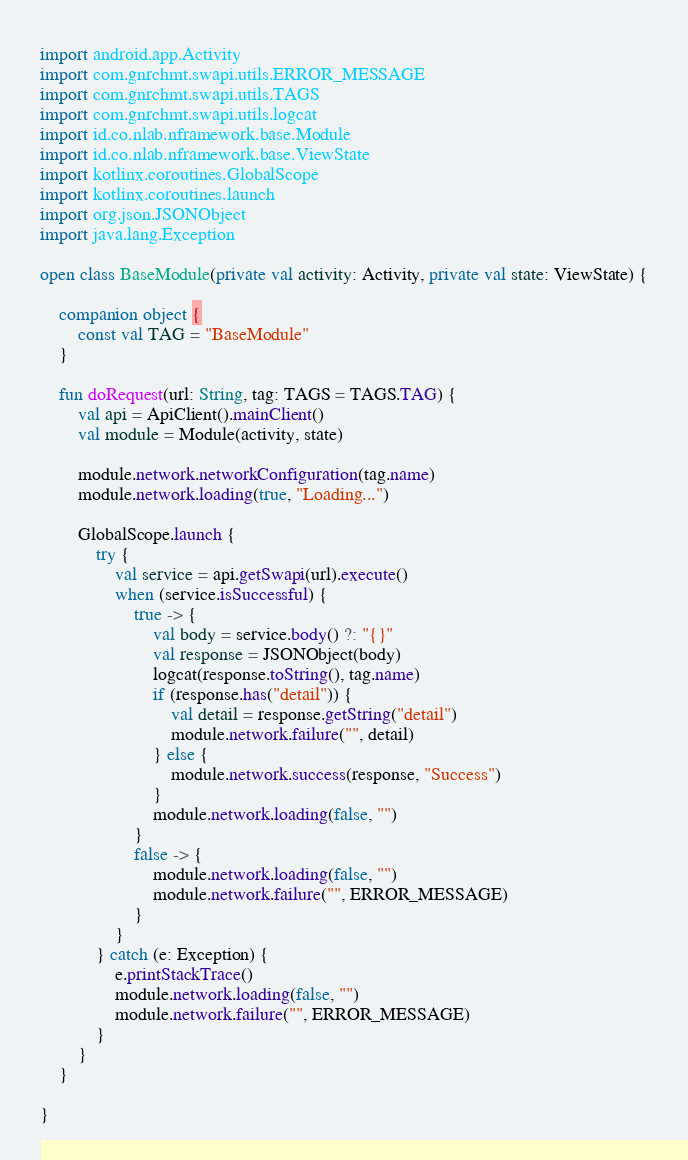Convert code to text. <code><loc_0><loc_0><loc_500><loc_500><_Kotlin_>
import android.app.Activity
import com.gnrchmt.swapi.utils.ERROR_MESSAGE
import com.gnrchmt.swapi.utils.TAGS
import com.gnrchmt.swapi.utils.logcat
import id.co.nlab.nframework.base.Module
import id.co.nlab.nframework.base.ViewState
import kotlinx.coroutines.GlobalScope
import kotlinx.coroutines.launch
import org.json.JSONObject
import java.lang.Exception

open class BaseModule(private val activity: Activity, private val state: ViewState) {

    companion object {
        const val TAG = "BaseModule"
    }

    fun doRequest(url: String, tag: TAGS = TAGS.TAG) {
        val api = ApiClient().mainClient()
        val module = Module(activity, state)

        module.network.networkConfiguration(tag.name)
        module.network.loading(true, "Loading...")

        GlobalScope.launch {
            try {
                val service = api.getSwapi(url).execute()
                when (service.isSuccessful) {
                    true -> {
                        val body = service.body() ?: "{}"
                        val response = JSONObject(body)
                        logcat(response.toString(), tag.name)
                        if (response.has("detail")) {
                            val detail = response.getString("detail")
                            module.network.failure("", detail)
                        } else {
                            module.network.success(response, "Success")
                        }
                        module.network.loading(false, "")
                    }
                    false -> {
                        module.network.loading(false, "")
                        module.network.failure("", ERROR_MESSAGE)
                    }
                }
            } catch (e: Exception) {
                e.printStackTrace()
                module.network.loading(false, "")
                module.network.failure("", ERROR_MESSAGE)
            }
        }
    }

}</code> 